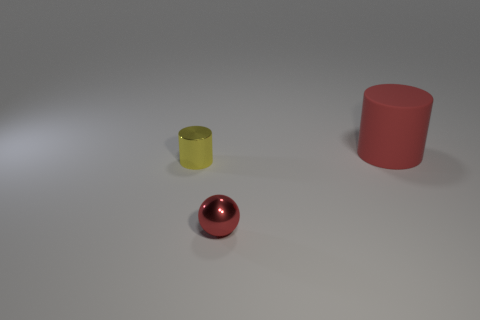Is the shape of the red thing that is in front of the red rubber thing the same as the red object that is behind the tiny yellow cylinder? no 